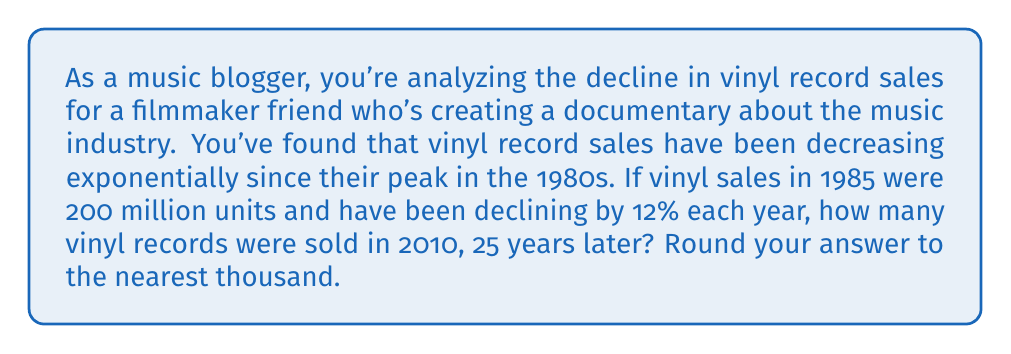Give your solution to this math problem. To solve this problem, we'll use the exponential decay formula:

$$A = P(1-r)^t$$

Where:
$A$ = Final amount
$P$ = Initial amount (200 million)
$r$ = Rate of decay (12% = 0.12)
$t$ = Time in years (25)

Let's substitute these values into the formula:

$$A = 200,000,000 \cdot (1-0.12)^{25}$$

Now, let's solve step-by-step:

1) First, calculate $(1-0.12)$:
   $1 - 0.12 = 0.88$

2) Now our equation looks like:
   $$A = 200,000,000 \cdot (0.88)^{25}$$

3) Calculate $(0.88)^{25}$:
   $(0.88)^{25} \approx 0.0461$ (rounded to 4 decimal places)

4) Multiply this by 200,000,000:
   $$A = 200,000,000 \cdot 0.0461 = 9,220,000$$

5) Round to the nearest thousand:
   9,220,000 rounds to 9,220,000

Therefore, approximately 9,220,000 vinyl records were sold in 2010.
Answer: 9,220,000 vinyl records 